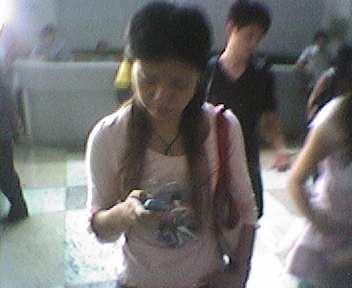What color is her shirt?
Quick response, please. Pink. What is this woman looking at?
Concise answer only. Cell phone. Is this photo in focus?
Be succinct. No. 